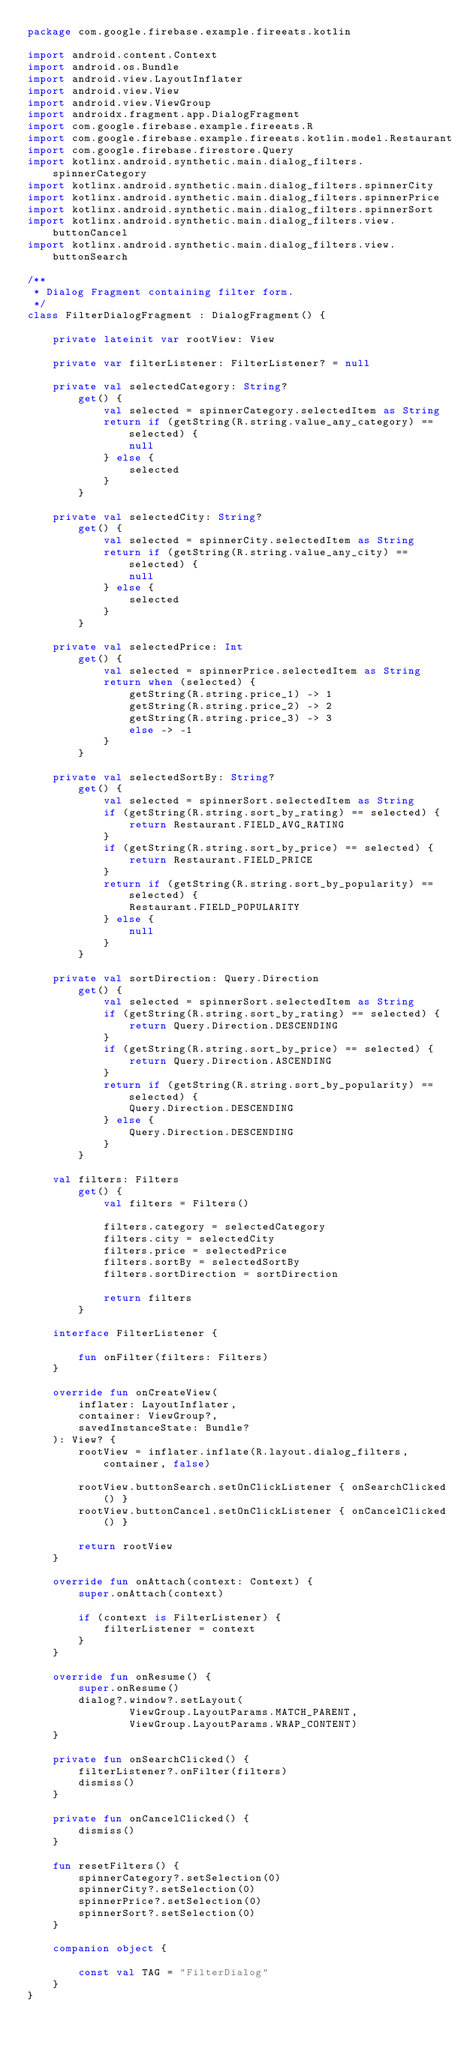Convert code to text. <code><loc_0><loc_0><loc_500><loc_500><_Kotlin_>package com.google.firebase.example.fireeats.kotlin

import android.content.Context
import android.os.Bundle
import android.view.LayoutInflater
import android.view.View
import android.view.ViewGroup
import androidx.fragment.app.DialogFragment
import com.google.firebase.example.fireeats.R
import com.google.firebase.example.fireeats.kotlin.model.Restaurant
import com.google.firebase.firestore.Query
import kotlinx.android.synthetic.main.dialog_filters.spinnerCategory
import kotlinx.android.synthetic.main.dialog_filters.spinnerCity
import kotlinx.android.synthetic.main.dialog_filters.spinnerPrice
import kotlinx.android.synthetic.main.dialog_filters.spinnerSort
import kotlinx.android.synthetic.main.dialog_filters.view.buttonCancel
import kotlinx.android.synthetic.main.dialog_filters.view.buttonSearch

/**
 * Dialog Fragment containing filter form.
 */
class FilterDialogFragment : DialogFragment() {

    private lateinit var rootView: View

    private var filterListener: FilterListener? = null

    private val selectedCategory: String?
        get() {
            val selected = spinnerCategory.selectedItem as String
            return if (getString(R.string.value_any_category) == selected) {
                null
            } else {
                selected
            }
        }

    private val selectedCity: String?
        get() {
            val selected = spinnerCity.selectedItem as String
            return if (getString(R.string.value_any_city) == selected) {
                null
            } else {
                selected
            }
        }

    private val selectedPrice: Int
        get() {
            val selected = spinnerPrice.selectedItem as String
            return when (selected) {
                getString(R.string.price_1) -> 1
                getString(R.string.price_2) -> 2
                getString(R.string.price_3) -> 3
                else -> -1
            }
        }

    private val selectedSortBy: String?
        get() {
            val selected = spinnerSort.selectedItem as String
            if (getString(R.string.sort_by_rating) == selected) {
                return Restaurant.FIELD_AVG_RATING
            }
            if (getString(R.string.sort_by_price) == selected) {
                return Restaurant.FIELD_PRICE
            }
            return if (getString(R.string.sort_by_popularity) == selected) {
                Restaurant.FIELD_POPULARITY
            } else {
                null
            }
        }

    private val sortDirection: Query.Direction
        get() {
            val selected = spinnerSort.selectedItem as String
            if (getString(R.string.sort_by_rating) == selected) {
                return Query.Direction.DESCENDING
            }
            if (getString(R.string.sort_by_price) == selected) {
                return Query.Direction.ASCENDING
            }
            return if (getString(R.string.sort_by_popularity) == selected) {
                Query.Direction.DESCENDING
            } else {
                Query.Direction.DESCENDING
            }
        }

    val filters: Filters
        get() {
            val filters = Filters()

            filters.category = selectedCategory
            filters.city = selectedCity
            filters.price = selectedPrice
            filters.sortBy = selectedSortBy
            filters.sortDirection = sortDirection

            return filters
        }

    interface FilterListener {

        fun onFilter(filters: Filters)
    }

    override fun onCreateView(
        inflater: LayoutInflater,
        container: ViewGroup?,
        savedInstanceState: Bundle?
    ): View? {
        rootView = inflater.inflate(R.layout.dialog_filters, container, false)

        rootView.buttonSearch.setOnClickListener { onSearchClicked() }
        rootView.buttonCancel.setOnClickListener { onCancelClicked() }

        return rootView
    }

    override fun onAttach(context: Context) {
        super.onAttach(context)

        if (context is FilterListener) {
            filterListener = context
        }
    }

    override fun onResume() {
        super.onResume()
        dialog?.window?.setLayout(
                ViewGroup.LayoutParams.MATCH_PARENT,
                ViewGroup.LayoutParams.WRAP_CONTENT)
    }

    private fun onSearchClicked() {
        filterListener?.onFilter(filters)
        dismiss()
    }

    private fun onCancelClicked() {
        dismiss()
    }

    fun resetFilters() {
        spinnerCategory?.setSelection(0)
        spinnerCity?.setSelection(0)
        spinnerPrice?.setSelection(0)
        spinnerSort?.setSelection(0)
    }

    companion object {

        const val TAG = "FilterDialog"
    }
}
</code> 